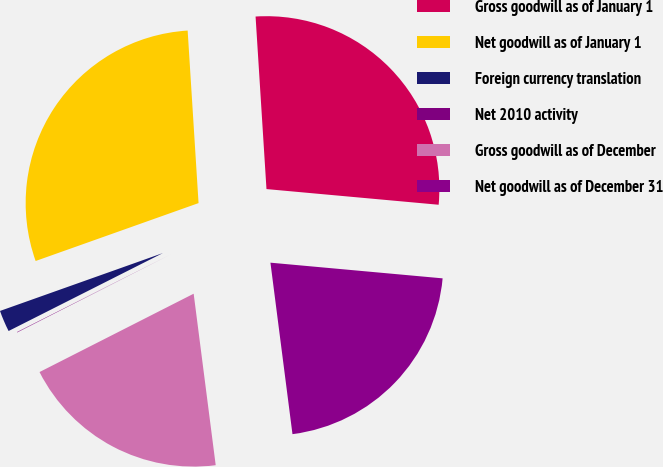<chart> <loc_0><loc_0><loc_500><loc_500><pie_chart><fcel>Gross goodwill as of January 1<fcel>Net goodwill as of January 1<fcel>Foreign currency translation<fcel>Net 2010 activity<fcel>Gross goodwill as of December<fcel>Net goodwill as of December 31<nl><fcel>27.45%<fcel>29.43%<fcel>2.01%<fcel>0.04%<fcel>19.55%<fcel>21.52%<nl></chart> 